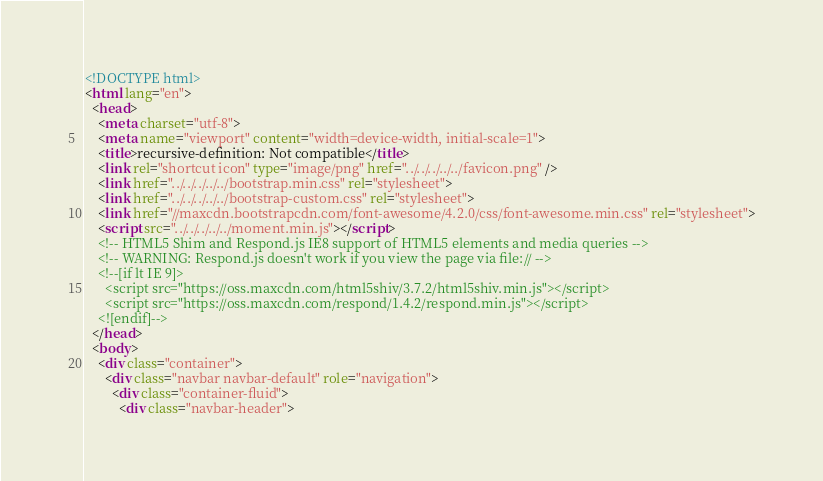Convert code to text. <code><loc_0><loc_0><loc_500><loc_500><_HTML_><!DOCTYPE html>
<html lang="en">
  <head>
    <meta charset="utf-8">
    <meta name="viewport" content="width=device-width, initial-scale=1">
    <title>recursive-definition: Not compatible</title>
    <link rel="shortcut icon" type="image/png" href="../../../../../favicon.png" />
    <link href="../../../../../bootstrap.min.css" rel="stylesheet">
    <link href="../../../../../bootstrap-custom.css" rel="stylesheet">
    <link href="//maxcdn.bootstrapcdn.com/font-awesome/4.2.0/css/font-awesome.min.css" rel="stylesheet">
    <script src="../../../../../moment.min.js"></script>
    <!-- HTML5 Shim and Respond.js IE8 support of HTML5 elements and media queries -->
    <!-- WARNING: Respond.js doesn't work if you view the page via file:// -->
    <!--[if lt IE 9]>
      <script src="https://oss.maxcdn.com/html5shiv/3.7.2/html5shiv.min.js"></script>
      <script src="https://oss.maxcdn.com/respond/1.4.2/respond.min.js"></script>
    <![endif]-->
  </head>
  <body>
    <div class="container">
      <div class="navbar navbar-default" role="navigation">
        <div class="container-fluid">
          <div class="navbar-header"></code> 